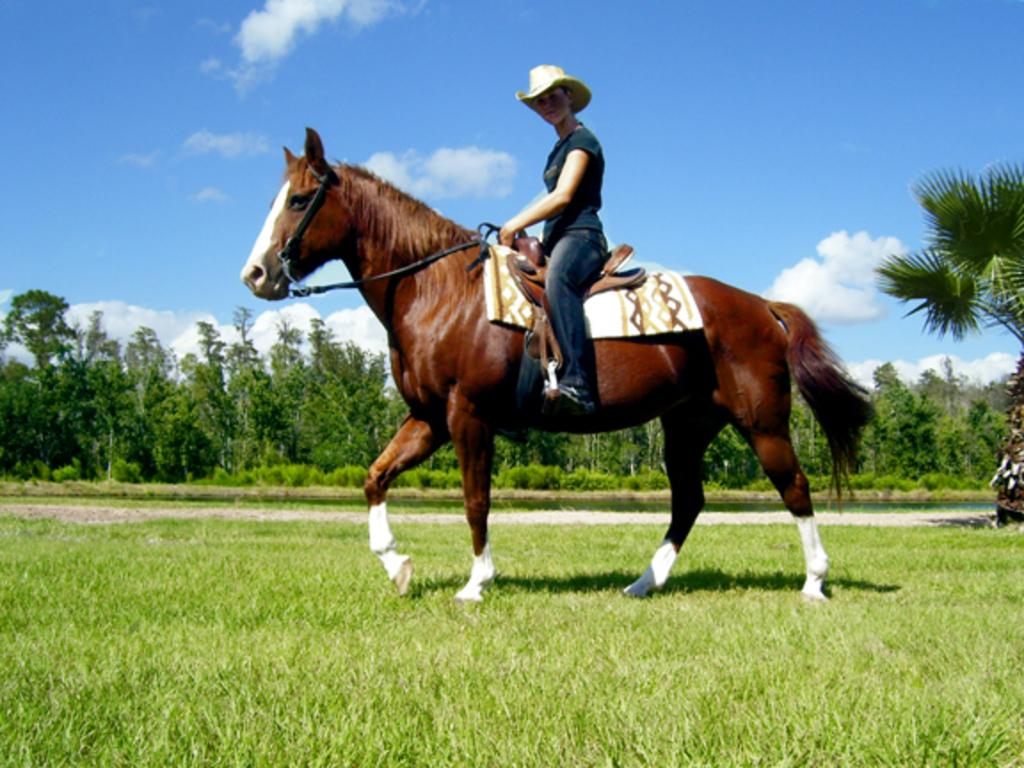What type of vegetation is at the bottom of the image? There is grass at the bottom of the image. What can be seen in the middle of the image besides the horse? There are trees in the middle of the image. What is visible at the top of the image? The sky is visible at the top of the image. What animal is present in the image? There is a horse in the middle of the image. What is the person on the horse doing? The person is sitting on the horse. What type of whistle can be heard in the image? There is no whistle present in the image, and therefore no sound can be heard. How many chairs are visible in the image? There are no chairs visible in the image. 